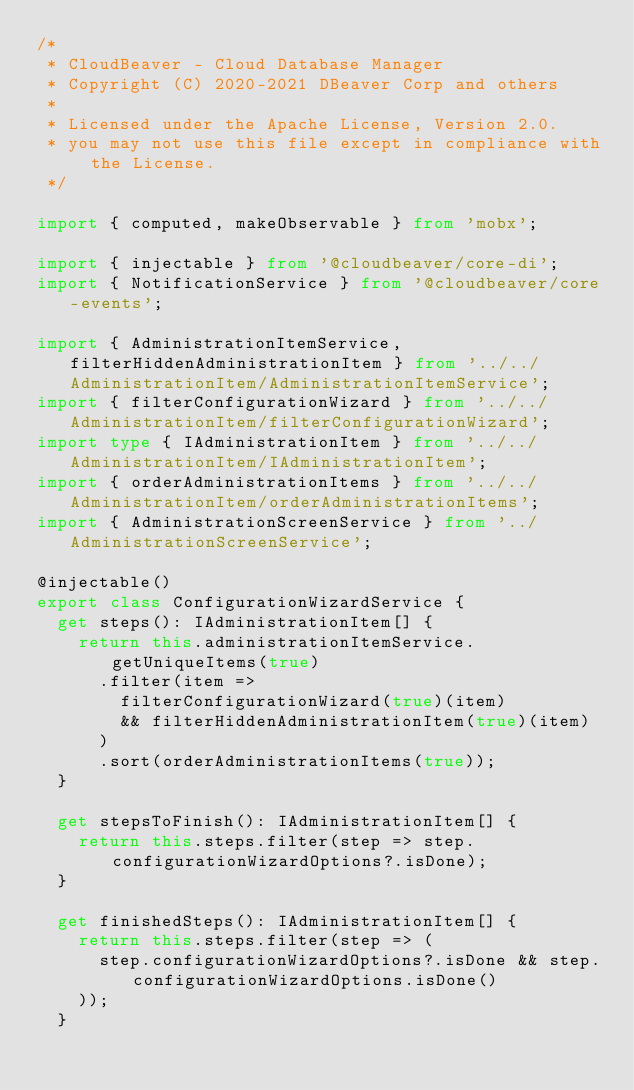<code> <loc_0><loc_0><loc_500><loc_500><_TypeScript_>/*
 * CloudBeaver - Cloud Database Manager
 * Copyright (C) 2020-2021 DBeaver Corp and others
 *
 * Licensed under the Apache License, Version 2.0.
 * you may not use this file except in compliance with the License.
 */

import { computed, makeObservable } from 'mobx';

import { injectable } from '@cloudbeaver/core-di';
import { NotificationService } from '@cloudbeaver/core-events';

import { AdministrationItemService, filterHiddenAdministrationItem } from '../../AdministrationItem/AdministrationItemService';
import { filterConfigurationWizard } from '../../AdministrationItem/filterConfigurationWizard';
import type { IAdministrationItem } from '../../AdministrationItem/IAdministrationItem';
import { orderAdministrationItems } from '../../AdministrationItem/orderAdministrationItems';
import { AdministrationScreenService } from '../AdministrationScreenService';

@injectable()
export class ConfigurationWizardService {
  get steps(): IAdministrationItem[] {
    return this.administrationItemService.getUniqueItems(true)
      .filter(item =>
        filterConfigurationWizard(true)(item)
        && filterHiddenAdministrationItem(true)(item)
      )
      .sort(orderAdministrationItems(true));
  }

  get stepsToFinish(): IAdministrationItem[] {
    return this.steps.filter(step => step.configurationWizardOptions?.isDone);
  }

  get finishedSteps(): IAdministrationItem[] {
    return this.steps.filter(step => (
      step.configurationWizardOptions?.isDone && step.configurationWizardOptions.isDone()
    ));
  }
</code> 